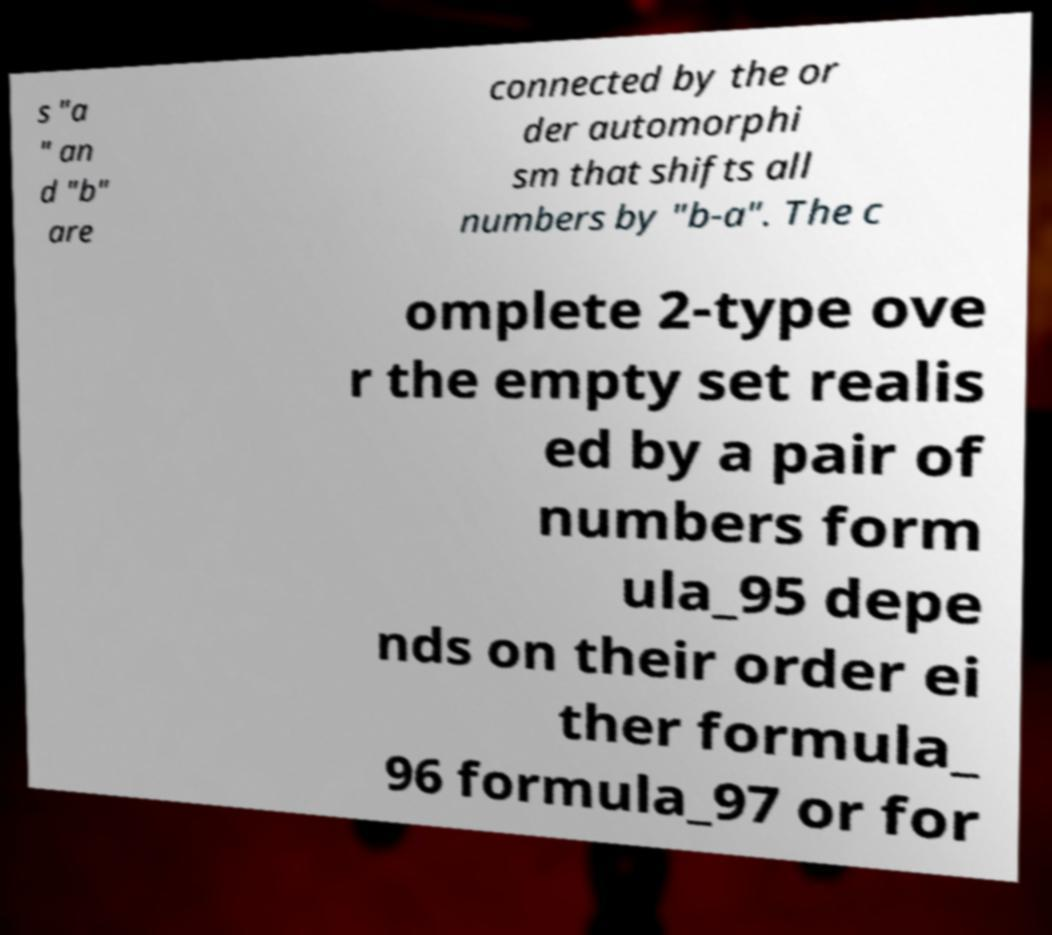Can you accurately transcribe the text from the provided image for me? s "a " an d "b" are connected by the or der automorphi sm that shifts all numbers by "b-a". The c omplete 2-type ove r the empty set realis ed by a pair of numbers form ula_95 depe nds on their order ei ther formula_ 96 formula_97 or for 